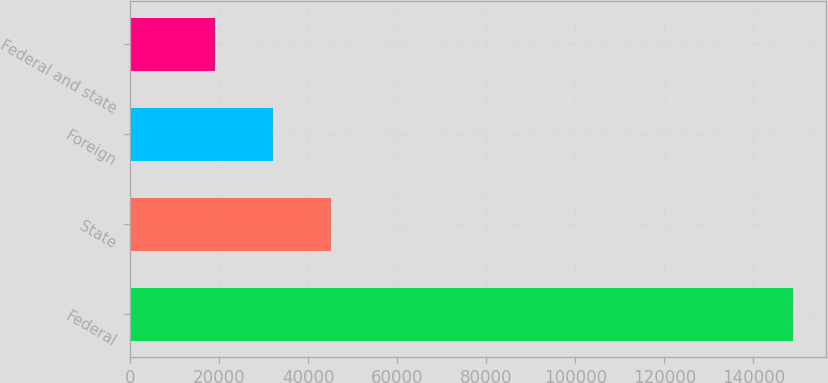Convert chart. <chart><loc_0><loc_0><loc_500><loc_500><bar_chart><fcel>Federal<fcel>State<fcel>Foreign<fcel>Federal and state<nl><fcel>148926<fcel>45062<fcel>32079<fcel>19096<nl></chart> 